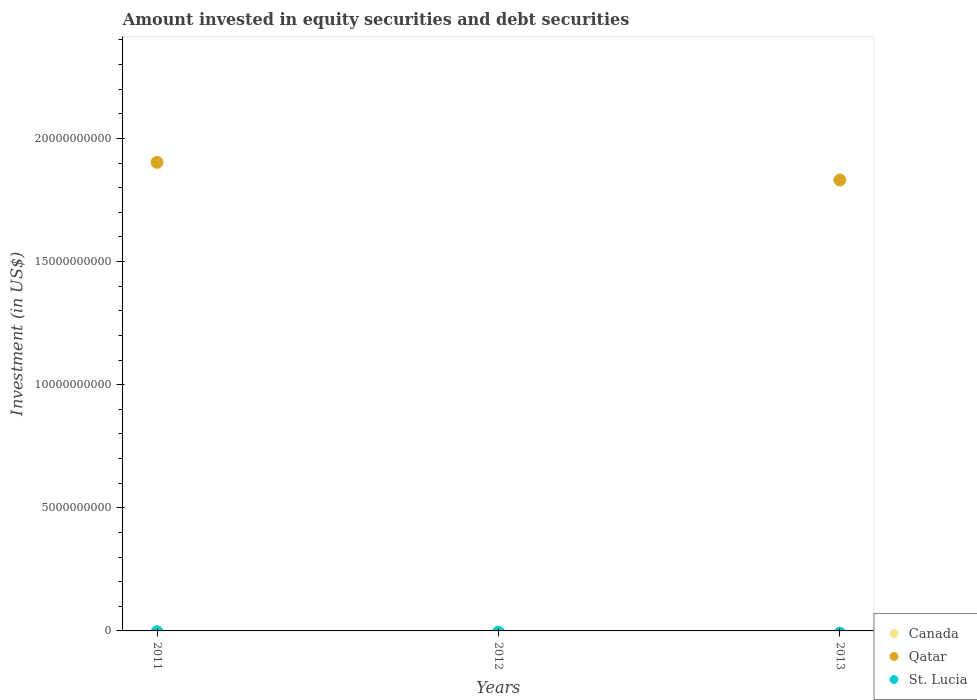How many different coloured dotlines are there?
Make the answer very short. 1. Is the number of dotlines equal to the number of legend labels?
Your answer should be compact. No. Across all years, what is the maximum amount invested in equity securities and debt securities in Qatar?
Offer a very short reply. 1.90e+1. What is the total amount invested in equity securities and debt securities in St. Lucia in the graph?
Provide a succinct answer. 0. What is the difference between the amount invested in equity securities and debt securities in Qatar in 2011 and that in 2013?
Give a very brief answer. 7.18e+08. What is the difference between the amount invested in equity securities and debt securities in Canada in 2013 and the amount invested in equity securities and debt securities in St. Lucia in 2012?
Ensure brevity in your answer.  0. What is the average amount invested in equity securities and debt securities in Qatar per year?
Offer a very short reply. 1.24e+1. In how many years, is the amount invested in equity securities and debt securities in St. Lucia greater than 13000000000 US$?
Your response must be concise. 0. What is the difference between the highest and the lowest amount invested in equity securities and debt securities in Qatar?
Give a very brief answer. 1.90e+1. Is the sum of the amount invested in equity securities and debt securities in Qatar in 2011 and 2013 greater than the maximum amount invested in equity securities and debt securities in Canada across all years?
Provide a succinct answer. Yes. Is the amount invested in equity securities and debt securities in Canada strictly greater than the amount invested in equity securities and debt securities in Qatar over the years?
Give a very brief answer. No. How many dotlines are there?
Keep it short and to the point. 1. Are the values on the major ticks of Y-axis written in scientific E-notation?
Make the answer very short. No. Does the graph contain grids?
Offer a very short reply. No. Where does the legend appear in the graph?
Keep it short and to the point. Bottom right. How many legend labels are there?
Make the answer very short. 3. What is the title of the graph?
Make the answer very short. Amount invested in equity securities and debt securities. What is the label or title of the Y-axis?
Offer a very short reply. Investment (in US$). What is the Investment (in US$) in Canada in 2011?
Your answer should be compact. 0. What is the Investment (in US$) in Qatar in 2011?
Provide a short and direct response. 1.90e+1. What is the Investment (in US$) of St. Lucia in 2012?
Offer a terse response. 0. What is the Investment (in US$) in Canada in 2013?
Make the answer very short. 0. What is the Investment (in US$) of Qatar in 2013?
Keep it short and to the point. 1.83e+1. Across all years, what is the maximum Investment (in US$) of Qatar?
Your answer should be compact. 1.90e+1. What is the total Investment (in US$) of Qatar in the graph?
Your answer should be compact. 3.73e+1. What is the difference between the Investment (in US$) of Qatar in 2011 and that in 2013?
Your answer should be very brief. 7.18e+08. What is the average Investment (in US$) in Canada per year?
Keep it short and to the point. 0. What is the average Investment (in US$) of Qatar per year?
Give a very brief answer. 1.24e+1. What is the average Investment (in US$) in St. Lucia per year?
Offer a very short reply. 0. What is the ratio of the Investment (in US$) of Qatar in 2011 to that in 2013?
Your response must be concise. 1.04. What is the difference between the highest and the lowest Investment (in US$) in Qatar?
Your answer should be very brief. 1.90e+1. 